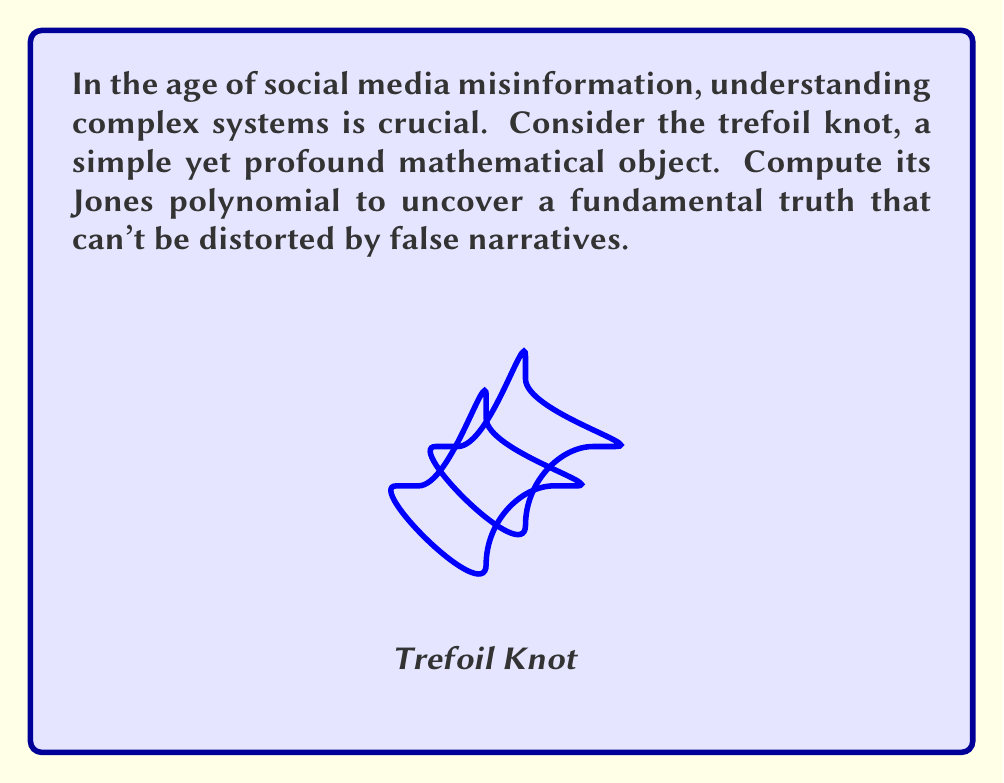Can you answer this question? To compute the Jones polynomial of the trefoil knot, we'll follow these steps:

1) First, we need to create the Kauffman bracket polynomial. For the trefoil knot, we have:

   $$\langle \text{trefoil} \rangle = A^7 - A^3 - A^{-5}$$

2) Next, we need to calculate the writhe of the trefoil knot. The standard diagram of the trefoil has three positive crossings, so the writhe is 3.

3) The Jones polynomial $V(t)$ is related to the Kauffman bracket $\langle K \rangle$ by:

   $$V(t) = (-A^{-3})^{-\text{writhe}} \cdot \langle K \rangle |_{A = t^{-1/4}}$$

4) Substituting our values:

   $$V(t) = (-A^{-3})^{-3} \cdot (A^7 - A^3 - A^{-5})$$

5) Simplify:

   $$V(t) = -A^9 \cdot (A^7 - A^3 - A^{-5})$$
   $$= -A^{16} + A^{12} + A^4$$

6) Now, substitute $A = t^{-1/4}$:

   $$V(t) = -(t^{-1/4})^{16} + (t^{-1/4})^{12} + (t^{-1/4})^4$$
   $$= -t^{-4} + t^{-3} + t^{-1}$$

7) Finally, multiply by $-1$ to get the standard form:

   $$V(t) = t^{-4} - t^{-3} - t^{-1}$$

This polynomial is a topological invariant of the trefoil knot, representing a fundamental truth about its structure that remains constant regardless of how the knot is manipulated or presented.
Answer: $V(t) = t^{-4} - t^{-3} - t^{-1}$ 